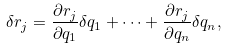Convert formula to latex. <formula><loc_0><loc_0><loc_500><loc_500>\delta r _ { j } = { \frac { \partial r _ { j } } { \partial q _ { 1 } } } \delta { q } _ { 1 } + \dots + { \frac { \partial r _ { j } } { \partial q _ { n } } } \delta { q } _ { n } ,</formula> 